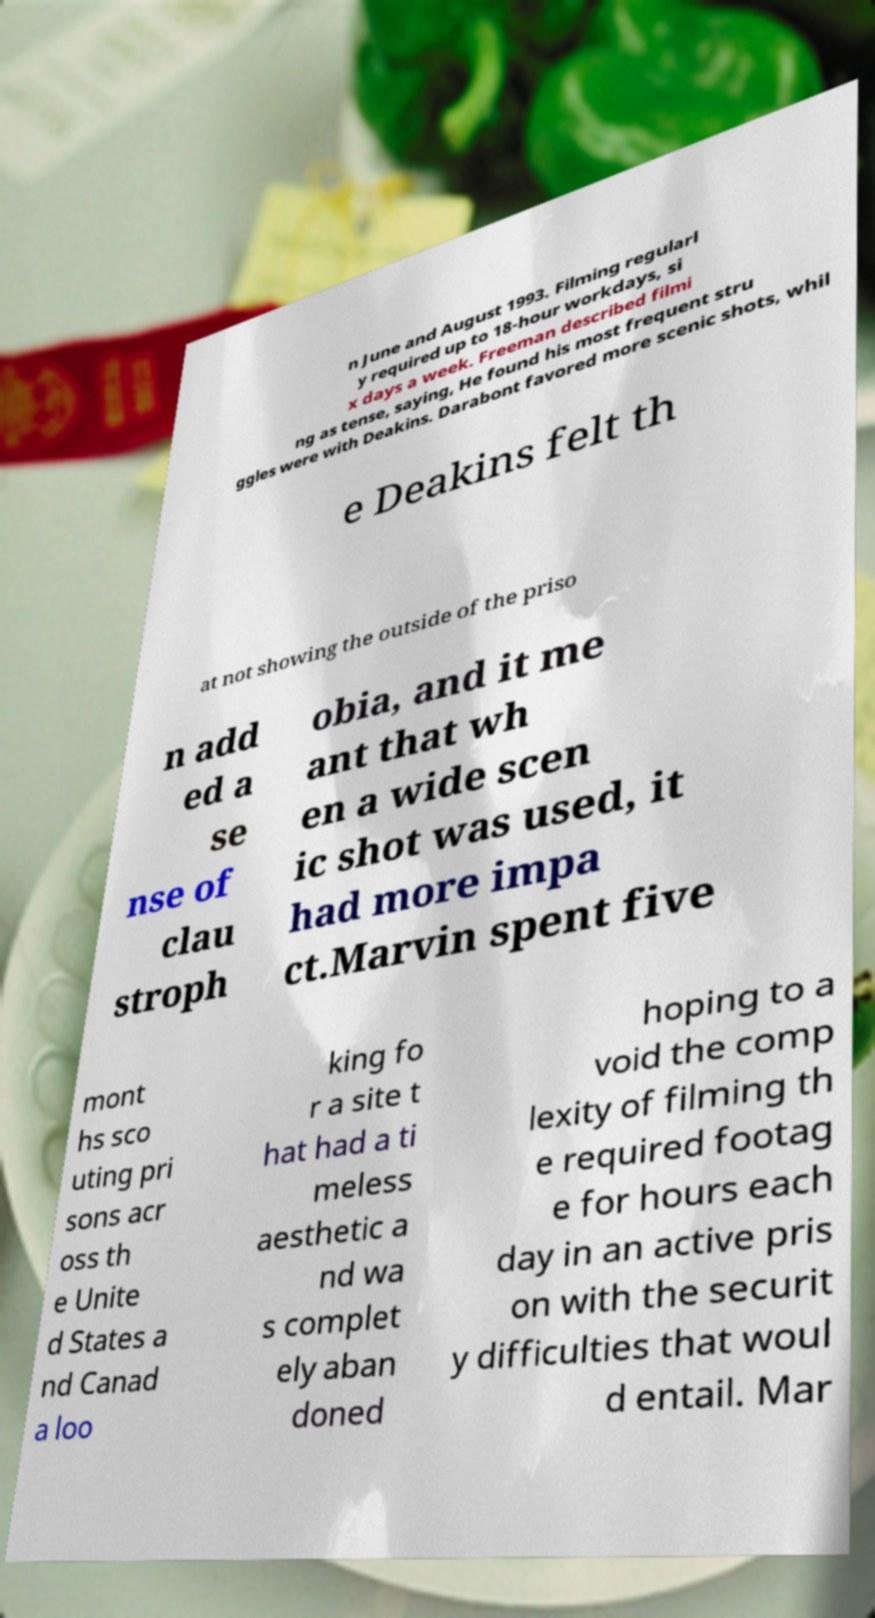Please identify and transcribe the text found in this image. n June and August 1993. Filming regularl y required up to 18-hour workdays, si x days a week. Freeman described filmi ng as tense, saying, He found his most frequent stru ggles were with Deakins. Darabont favored more scenic shots, whil e Deakins felt th at not showing the outside of the priso n add ed a se nse of clau stroph obia, and it me ant that wh en a wide scen ic shot was used, it had more impa ct.Marvin spent five mont hs sco uting pri sons acr oss th e Unite d States a nd Canad a loo king fo r a site t hat had a ti meless aesthetic a nd wa s complet ely aban doned hoping to a void the comp lexity of filming th e required footag e for hours each day in an active pris on with the securit y difficulties that woul d entail. Mar 